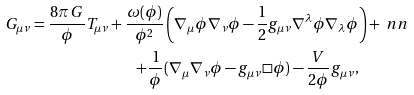Convert formula to latex. <formula><loc_0><loc_0><loc_500><loc_500>G _ { \mu \nu } = \frac { 8 \pi \, G } { \phi } T _ { \mu \nu } + \frac { \omega ( \phi ) } { \phi ^ { 2 } } & \left ( \nabla _ { \mu } \phi \nabla _ { \nu } \phi - \frac { 1 } { 2 } g _ { \mu \nu } \nabla ^ { \lambda } \phi \nabla _ { \lambda } \phi \right ) + \ n n \\ + \frac { 1 } { \phi } & ( \nabla _ { \mu } \nabla _ { \nu } \phi - g _ { \mu \nu } \Box \phi ) - \frac { V } { 2 \phi } g _ { \mu \nu } ,</formula> 